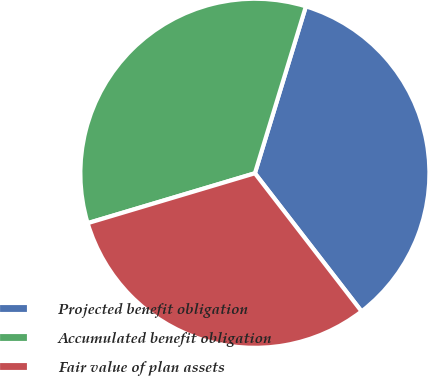Convert chart to OTSL. <chart><loc_0><loc_0><loc_500><loc_500><pie_chart><fcel>Projected benefit obligation<fcel>Accumulated benefit obligation<fcel>Fair value of plan assets<nl><fcel>34.81%<fcel>34.33%<fcel>30.85%<nl></chart> 